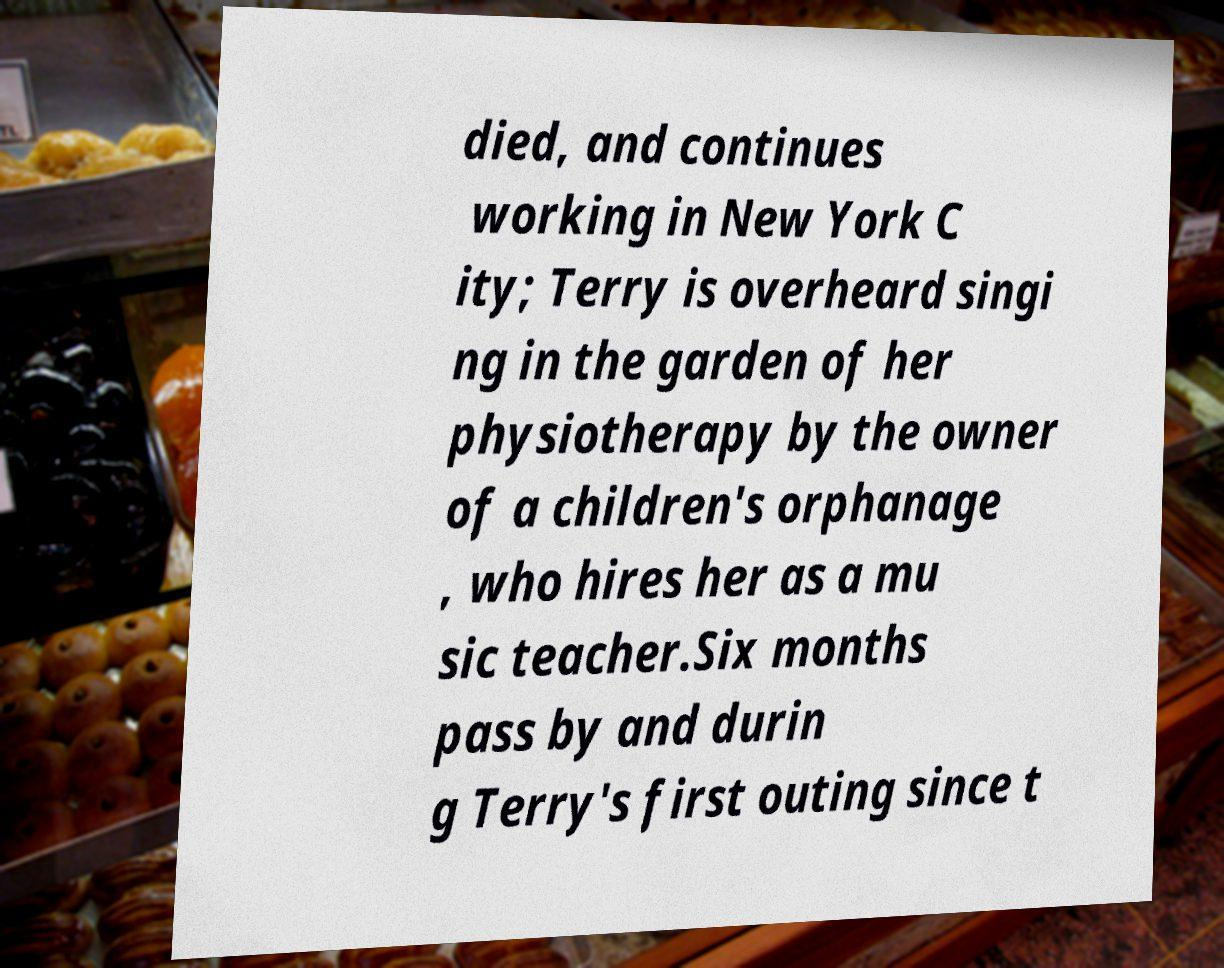There's text embedded in this image that I need extracted. Can you transcribe it verbatim? died, and continues working in New York C ity; Terry is overheard singi ng in the garden of her physiotherapy by the owner of a children's orphanage , who hires her as a mu sic teacher.Six months pass by and durin g Terry's first outing since t 